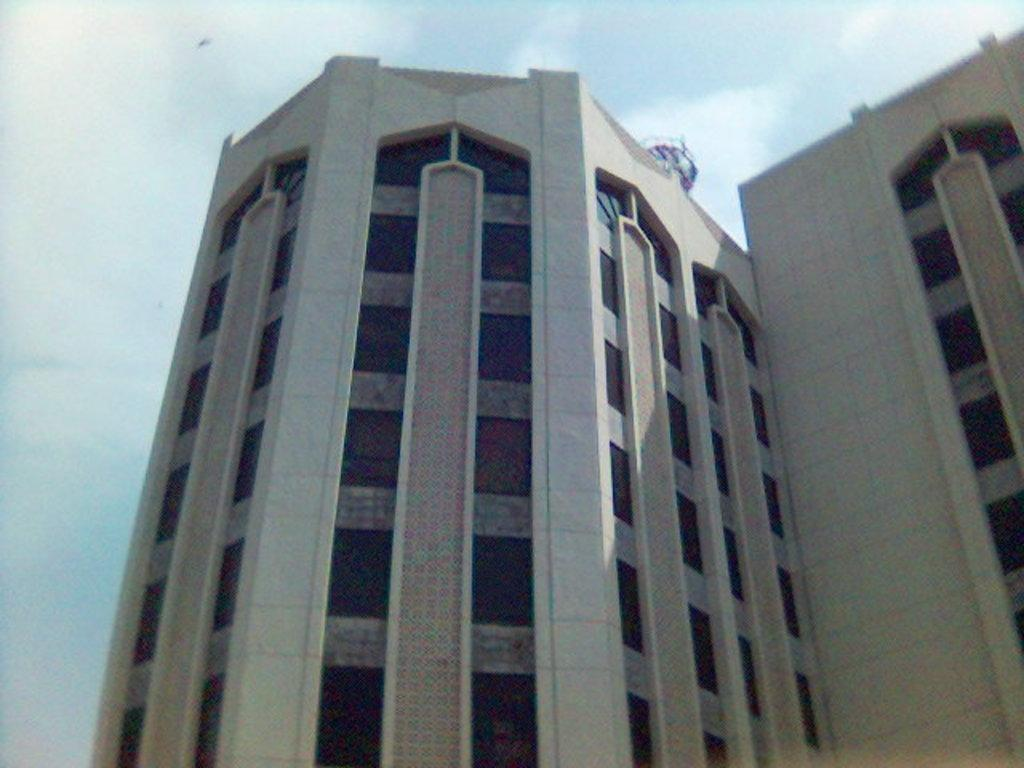What is the main structure in the image? A: There is a building in the image. What feature can be seen on the building? The building has windows. What is the condition of the sky in the image? The sky is covered with clouds in the image. What type of committee is meeting on the roof of the building in the image? There is no committee meeting on the roof of the building in the image, as there is no roof or committee mentioned in the provided facts. Can you hear the sound of someone's ear in the image? There is no mention of any sound or ear in the image, as the provided facts only discuss the building and the sky. 